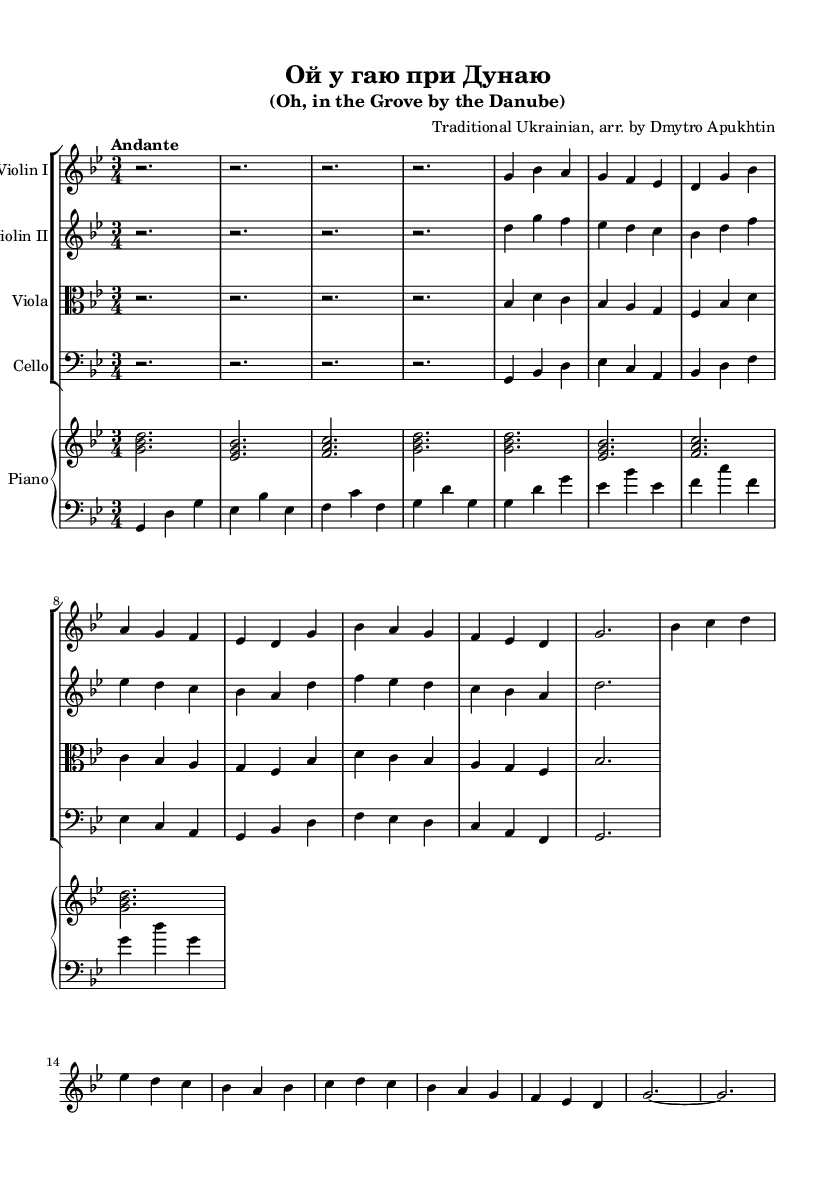What is the key signature of this music? The key signature is G minor, which consists of two flats (B♭ and E♭). This can be deduced from the initial indication in the global section of the LilyPond code where it specifies "\key g \minor".
Answer: G minor What is the time signature of this music? The time signature is 3/4, indicating that there are three beats per measure and the quarter note gets one beat. This can be confirmed by the specification in the global section of the LilyPond code with "\time 3/4".
Answer: 3/4 What is the tempo marking of this piece? The tempo marking is "Andante", which generally means a moderately slow pace. This is indicated directly in the global section of the LilyPond code where it is designated as "\tempo "Andante"".
Answer: Andante How many sections are present in the piece? There are two main sections identified as A and B. This can be observed from the structure where the A section is partially outlined first, followed by the indication of a B section. The coding comments label these sections clearly.
Answer: 2 What instruments are featured in this arrangement? The instruments featured are Violin I, Violin II, Viola, Cello, and Piano. This can be deduced from the score section where each instrument is defined as part of the StaffGroup and PianoStaff.
Answer: Violin I, Violin II, Viola, Cello, and Piano What does the term "arr." signify after the composer's name? The term "arr." signifies that the piece is an arrangement, which means it has been adapted for a specific ensemble or instrumentation from its original form. This is noted in the header of the sheet music stating "arr. by Dmytro Apukhtin".
Answer: arrangement 